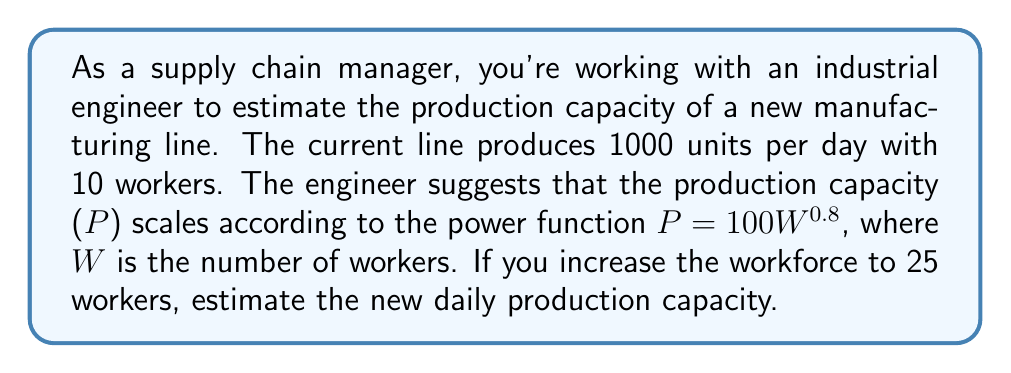Can you solve this math problem? Let's approach this step-by-step:

1) We're given the power function: $P = 100W^{0.8}$

2) First, let's verify if this function accurately represents the current situation:
   For 10 workers: $P = 100(10)^{0.8} = 100 * 6.31 = 631$ units
   This is lower than the actual 1000 units, but power functions are often approximations.

3) To estimate the new capacity with 25 workers, we simply plug in W = 25:

   $P = 100(25)^{0.8}$

4) Let's calculate this:
   $25^{0.8} = e^{0.8 * ln(25)} = e^{2.639} = 14.0$

5) Therefore:
   $P = 100 * 14.0 = 1400$ units

6) To double-check, we can calculate the ratio of increase:
   $\frac{25}{10} = 2.5$ (150% increase in workers)
   $\frac{1400}{1000} = 1.4$ (40% increase in production)

This aligns with the principle of diminishing returns, which is often modeled by power functions with exponents less than 1.
Answer: The estimated daily production capacity with 25 workers is approximately 1400 units. 